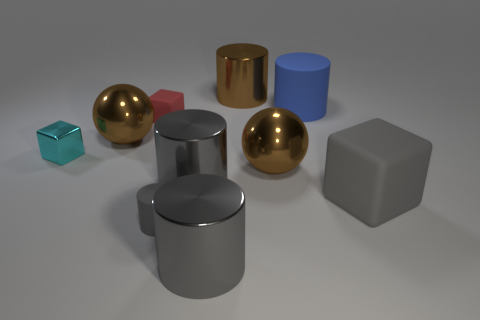How many gray cylinders must be subtracted to get 1 gray cylinders? 2 Subtract all cyan balls. How many gray cylinders are left? 3 Subtract all small cylinders. How many cylinders are left? 4 Subtract 3 cylinders. How many cylinders are left? 2 Subtract all brown cylinders. How many cylinders are left? 4 Subtract all blue cylinders. Subtract all green spheres. How many cylinders are left? 4 Subtract 0 red cylinders. How many objects are left? 10 Subtract all blocks. How many objects are left? 7 Subtract all tiny metallic things. Subtract all red cubes. How many objects are left? 8 Add 3 large blue rubber cylinders. How many large blue rubber cylinders are left? 4 